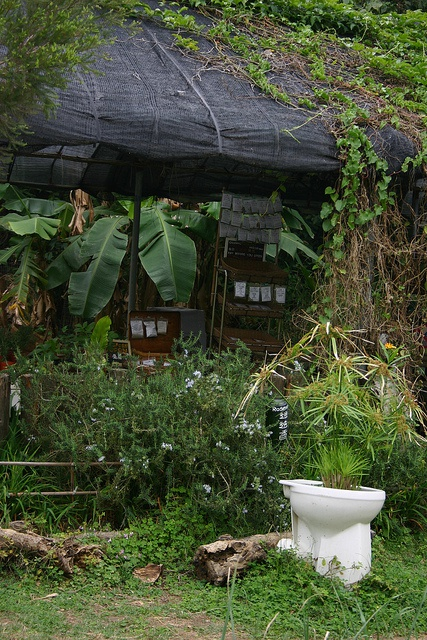Describe the objects in this image and their specific colors. I can see potted plant in darkgreen, lightgray, black, and darkgray tones and toilet in darkgreen, lightgray, darkgray, and gray tones in this image. 